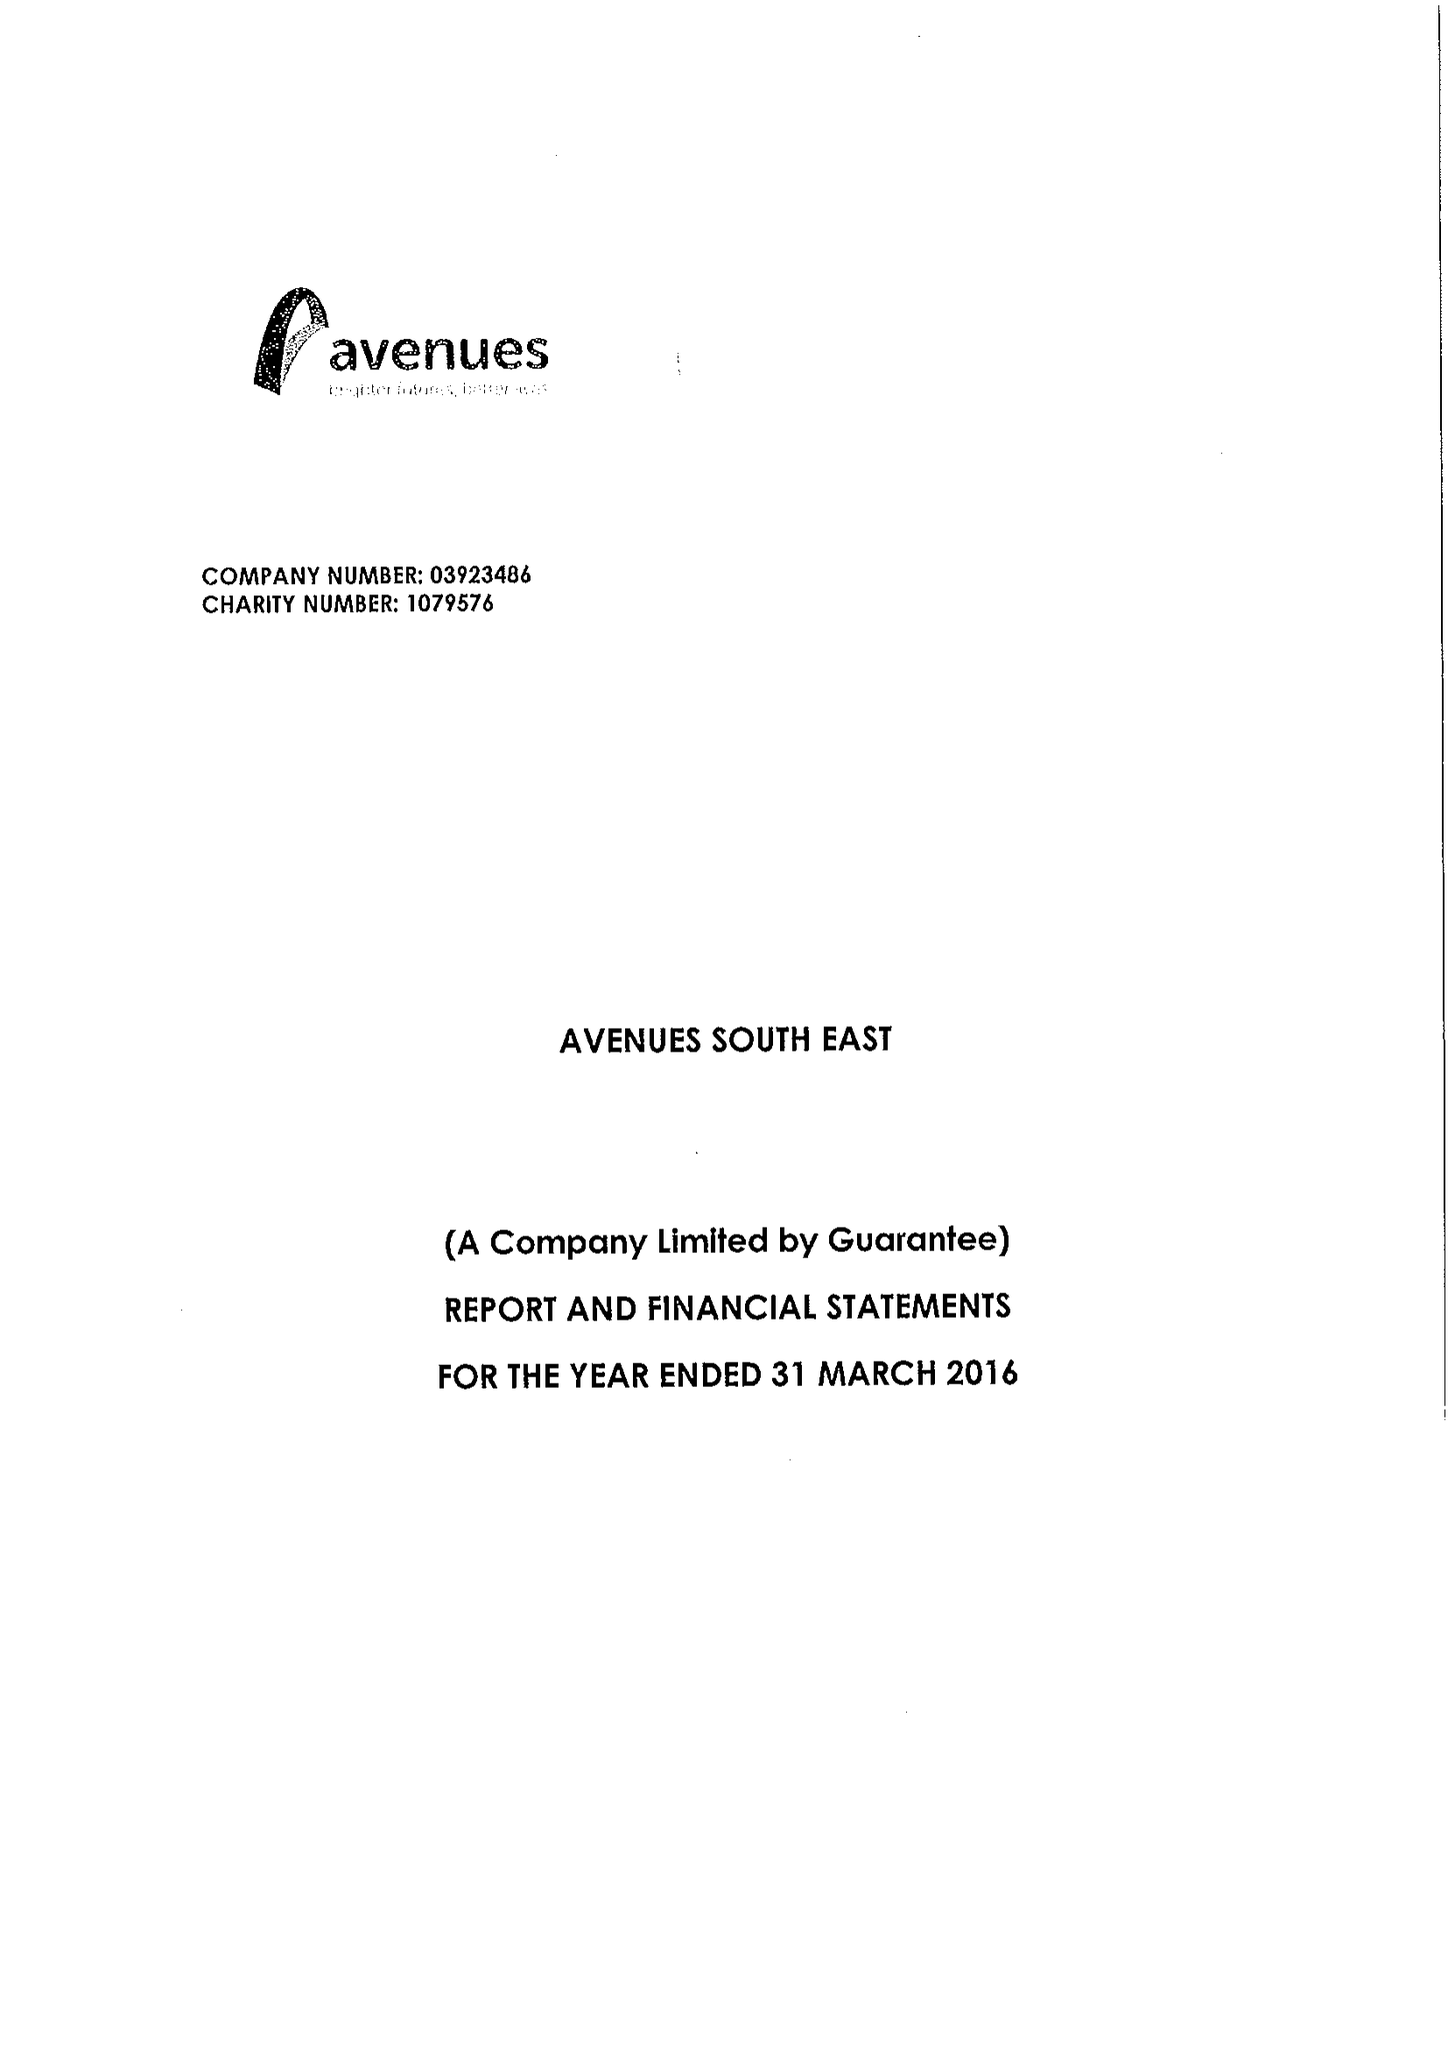What is the value for the report_date?
Answer the question using a single word or phrase. 2016-03-31 